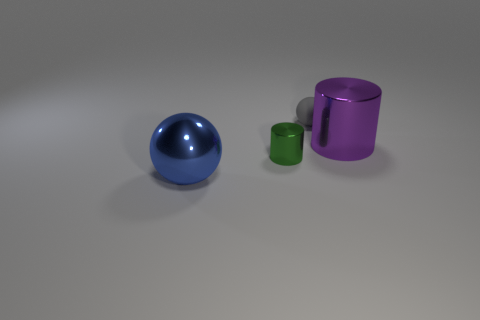Does the blue metal object have the same size as the matte sphere behind the green metallic object?
Give a very brief answer. No. There is a big metallic object in front of the shiny thing that is behind the small shiny thing; is there a large purple cylinder to the right of it?
Offer a terse response. Yes. What material is the sphere behind the big metal object to the left of the large purple metallic object?
Provide a short and direct response. Rubber. There is a thing that is both left of the purple metallic cylinder and behind the tiny green metal thing; what is its material?
Your answer should be very brief. Rubber. Is there a big thing of the same shape as the small matte object?
Offer a terse response. Yes. Is there a large purple metal cylinder in front of the gray rubber thing that is behind the green metal cylinder?
Give a very brief answer. Yes. How many large blue things have the same material as the tiny green thing?
Offer a very short reply. 1. Are any small cyan cubes visible?
Your response must be concise. No. Does the purple object have the same material as the big thing that is in front of the small green cylinder?
Your answer should be very brief. Yes. Is the number of green metal cylinders in front of the purple metallic thing greater than the number of small yellow objects?
Make the answer very short. Yes. 